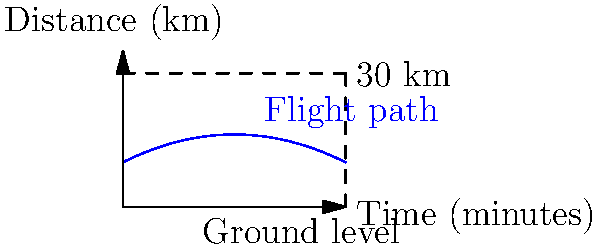During the War of 1812, carrier pigeons were crucial for delivering messages across battlefields. The flight path of a particular carrier pigeon can be modeled by the function $h(t) = -0.01t^2 + 0.5t + 10$, where $h$ is the height in kilometers and $t$ is the time in minutes. If the pigeon needs to deliver a message to a location 30 km away, at what time during its flight will the pigeon be exactly halfway to its destination in terms of horizontal distance? To solve this problem, we need to follow these steps:

1) The pigeon's horizontal position is not directly given by the function. We need to find when it reaches 15 km (half of 30 km).

2) The horizontal distance traveled is proportional to time. At the halfway point, half the total time will have elapsed.

3) Let's call the total flight time $T$. At time $T$, the pigeon travels 30 km.

4) At time $T/2$, the pigeon will have traveled 15 km.

5) We can find $T$ by solving the equation:
   
   $30 = 0.5T$
   
   $T = 60$ minutes

6) Therefore, the pigeon will be halfway (15 km) at time $T/2 = 30$ minutes.

7) To verify, we can calculate the height at this time:
   
   $h(30) = -0.01(30)^2 + 0.5(30) + 10 = -9 + 15 + 10 = 16$ km

So at 30 minutes, the pigeon will be 15 km horizontally from its starting point and 16 km above the ground.
Answer: 30 minutes 